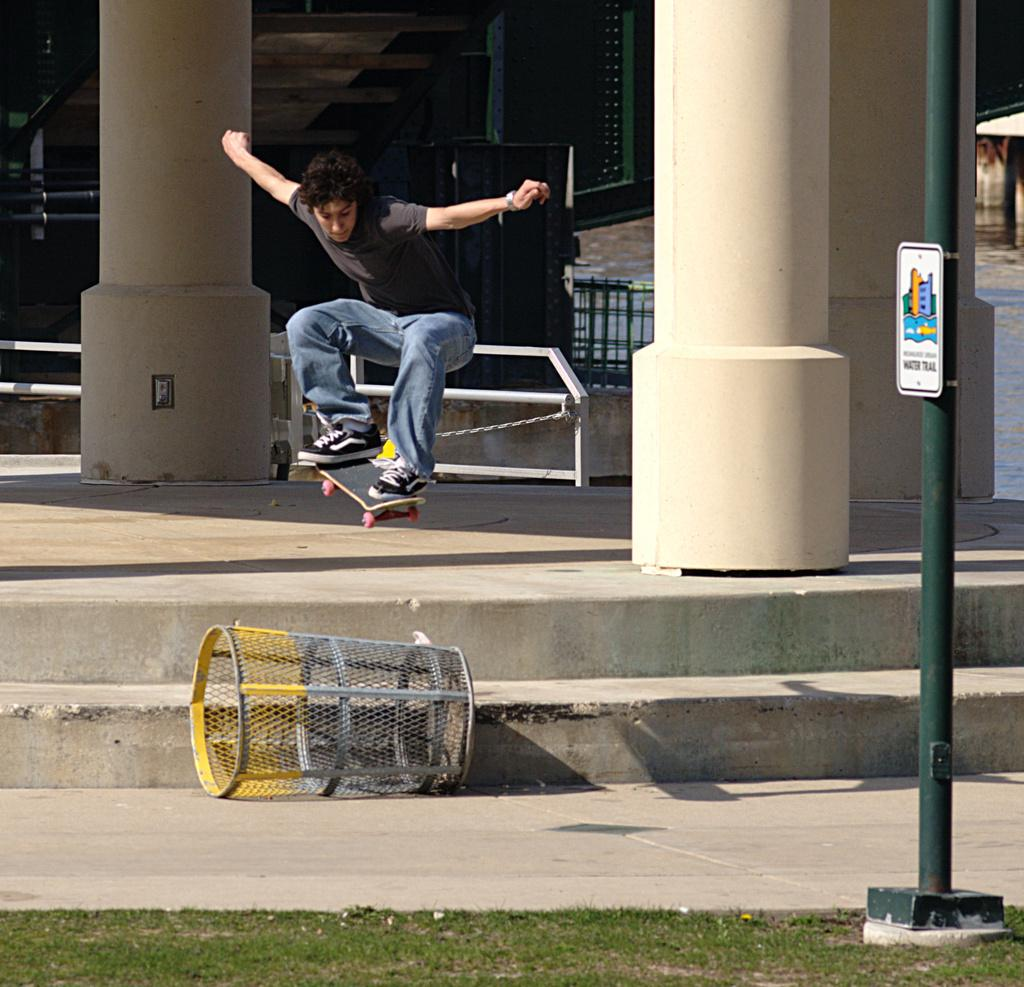What is the man in the image doing? There is a man skating in the image. What type of surface can be seen in the image? There is grass visible in the image. What object is on a pole in the image? There is a board on a pole in the image. What type of structure can be seen in the image? There are pillars in the image. What is used for waste disposal in the image? There is a bin on the surface in the image. What can be seen in the background of the image? There is a fence in the background of the image. What type of substance is being harvested from the apples in the image? There are no apples present in the image, so it is not possible to determine if any substance is being harvested from them. 